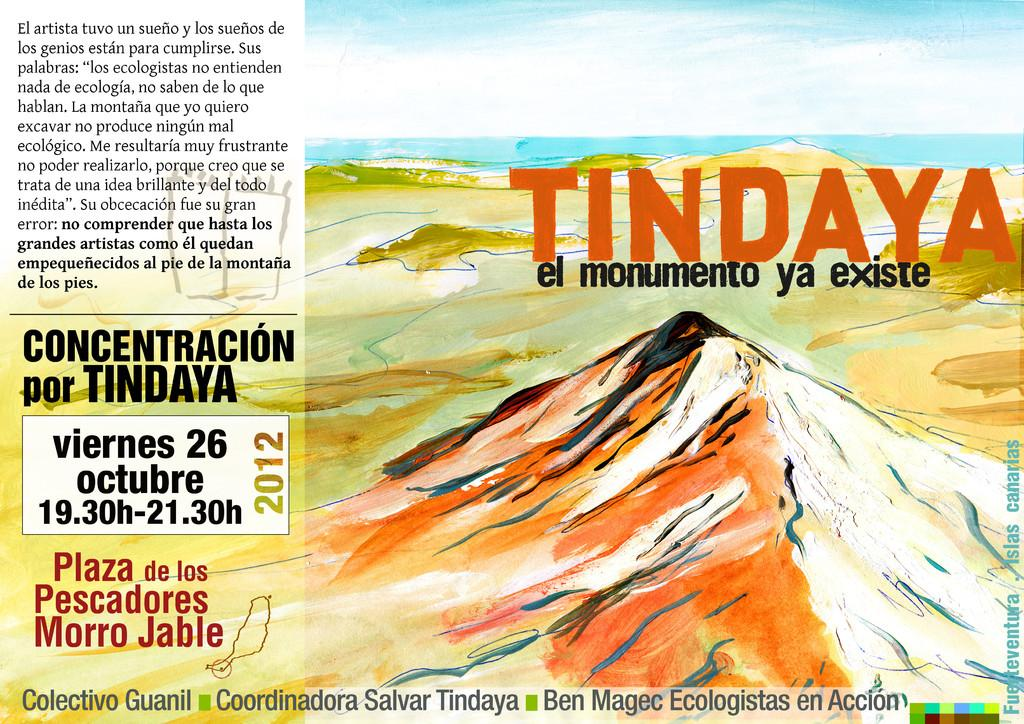What is featured on the poster in the image? There is a poster in the image that contains text. What elements are depicted on the poster? The poster depicts land, the sea, and the sky. What color is the crayon used to draw the light in the image? There is no crayon or light present in the image; it features a poster with text and depictions of land, sea, and sky. 